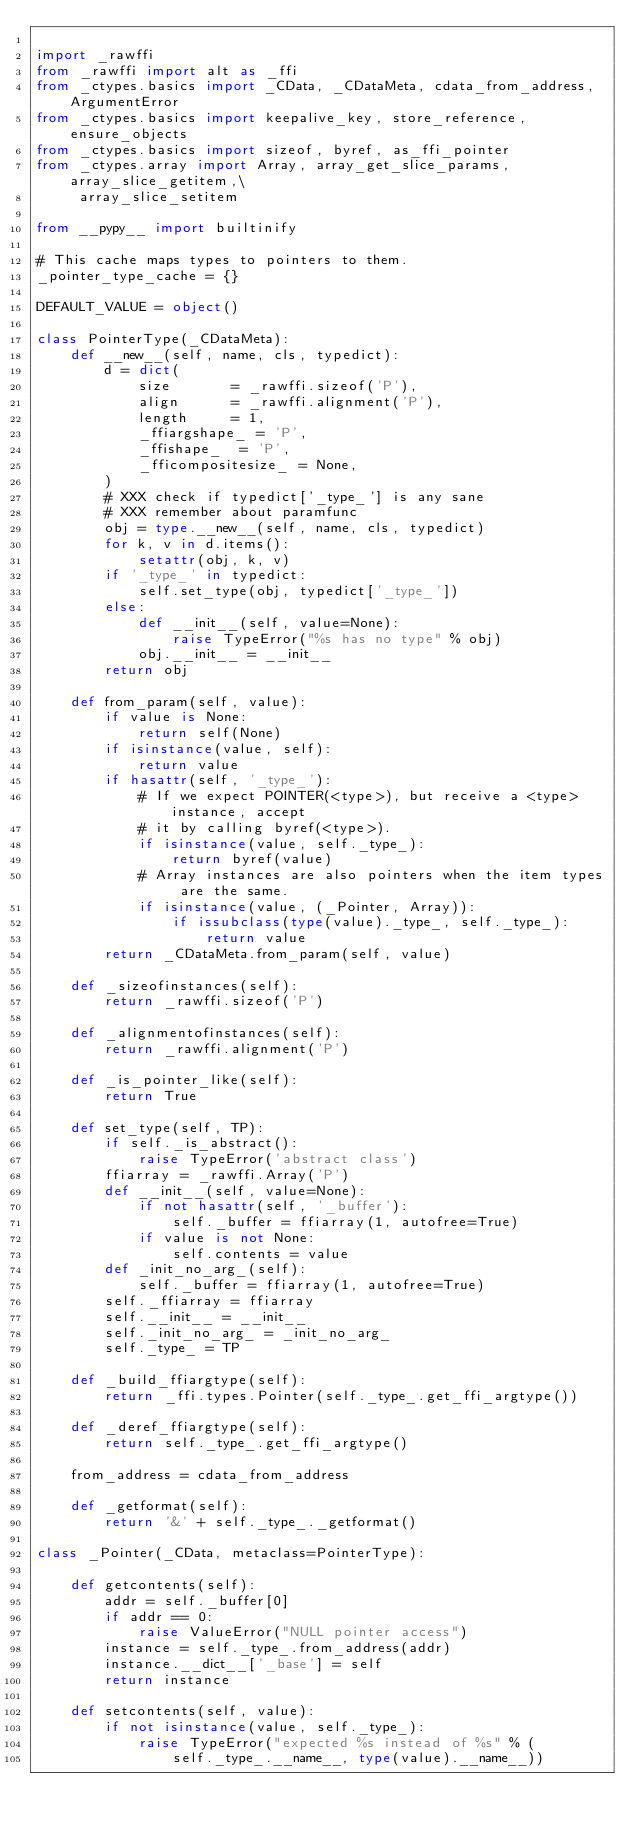<code> <loc_0><loc_0><loc_500><loc_500><_Python_>
import _rawffi
from _rawffi import alt as _ffi
from _ctypes.basics import _CData, _CDataMeta, cdata_from_address, ArgumentError
from _ctypes.basics import keepalive_key, store_reference, ensure_objects
from _ctypes.basics import sizeof, byref, as_ffi_pointer
from _ctypes.array import Array, array_get_slice_params, array_slice_getitem,\
     array_slice_setitem

from __pypy__ import builtinify

# This cache maps types to pointers to them.
_pointer_type_cache = {}

DEFAULT_VALUE = object()

class PointerType(_CDataMeta):
    def __new__(self, name, cls, typedict):
        d = dict(
            size       = _rawffi.sizeof('P'),
            align      = _rawffi.alignment('P'),
            length     = 1,
            _ffiargshape_ = 'P',
            _ffishape_  = 'P',
            _fficompositesize_ = None,
        )
        # XXX check if typedict['_type_'] is any sane
        # XXX remember about paramfunc
        obj = type.__new__(self, name, cls, typedict)
        for k, v in d.items():
            setattr(obj, k, v)
        if '_type_' in typedict:
            self.set_type(obj, typedict['_type_'])
        else:
            def __init__(self, value=None):
                raise TypeError("%s has no type" % obj)
            obj.__init__ = __init__
        return obj

    def from_param(self, value):
        if value is None:
            return self(None)
        if isinstance(value, self):
            return value
        if hasattr(self, '_type_'):
            # If we expect POINTER(<type>), but receive a <type> instance, accept
            # it by calling byref(<type>).
            if isinstance(value, self._type_):
                return byref(value)
            # Array instances are also pointers when the item types are the same.
            if isinstance(value, (_Pointer, Array)):
                if issubclass(type(value)._type_, self._type_):
                    return value
        return _CDataMeta.from_param(self, value)

    def _sizeofinstances(self):
        return _rawffi.sizeof('P')

    def _alignmentofinstances(self):
        return _rawffi.alignment('P')

    def _is_pointer_like(self):
        return True

    def set_type(self, TP):
        if self._is_abstract():
            raise TypeError('abstract class')
        ffiarray = _rawffi.Array('P')
        def __init__(self, value=None):
            if not hasattr(self, '_buffer'):
                self._buffer = ffiarray(1, autofree=True)
            if value is not None:
                self.contents = value
        def _init_no_arg_(self):
            self._buffer = ffiarray(1, autofree=True)
        self._ffiarray = ffiarray
        self.__init__ = __init__
        self._init_no_arg_ = _init_no_arg_
        self._type_ = TP

    def _build_ffiargtype(self):
        return _ffi.types.Pointer(self._type_.get_ffi_argtype())

    def _deref_ffiargtype(self):
        return self._type_.get_ffi_argtype()

    from_address = cdata_from_address

    def _getformat(self):
        return '&' + self._type_._getformat()

class _Pointer(_CData, metaclass=PointerType):

    def getcontents(self):
        addr = self._buffer[0]
        if addr == 0:
            raise ValueError("NULL pointer access")
        instance = self._type_.from_address(addr)
        instance.__dict__['_base'] = self
        return instance

    def setcontents(self, value):
        if not isinstance(value, self._type_):
            raise TypeError("expected %s instead of %s" % (
                self._type_.__name__, type(value).__name__))</code> 